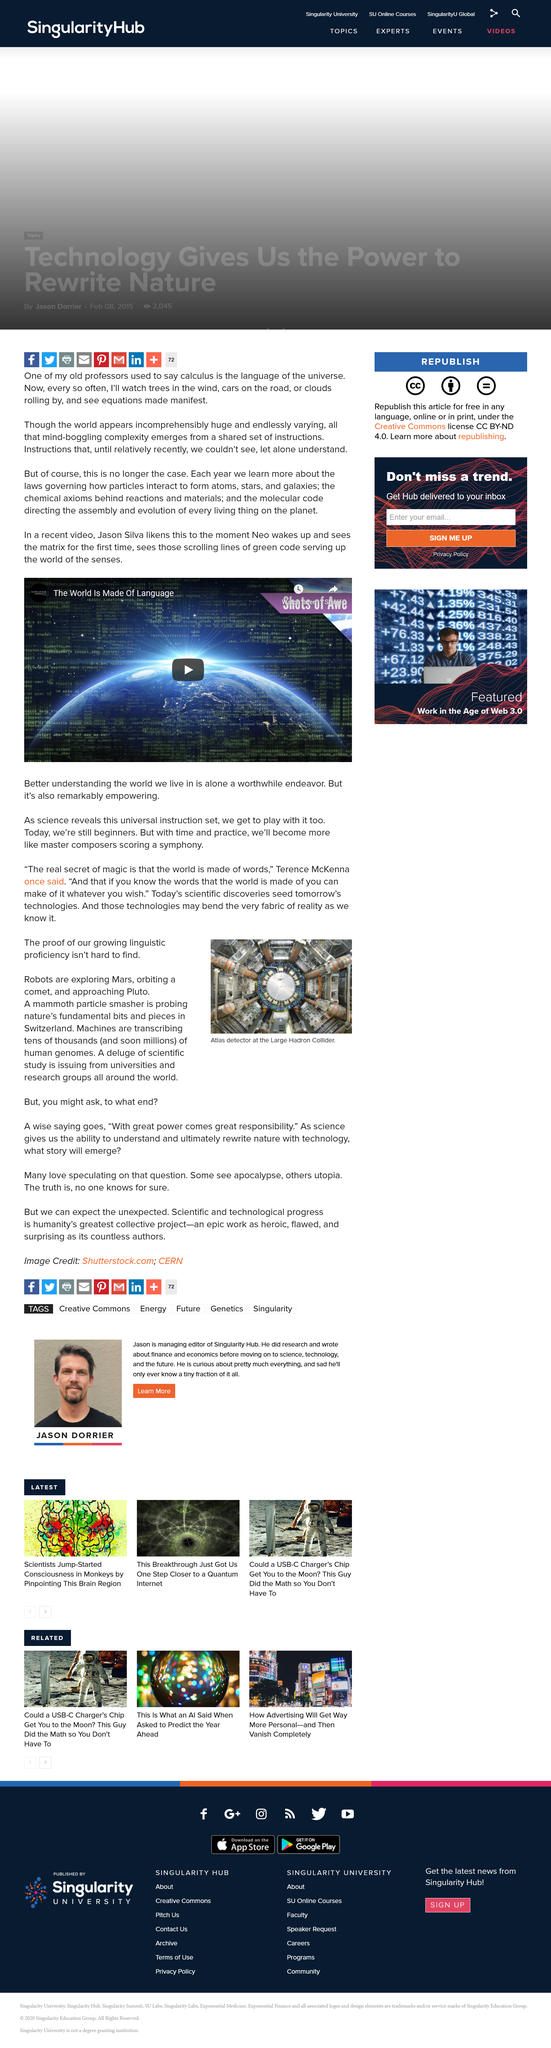Mention a couple of crucial points in this snapshot. The picture shows the atlas detector. Yes, there are robots exploring Mars. Machines are currently not transcribing millions of human genomes. 